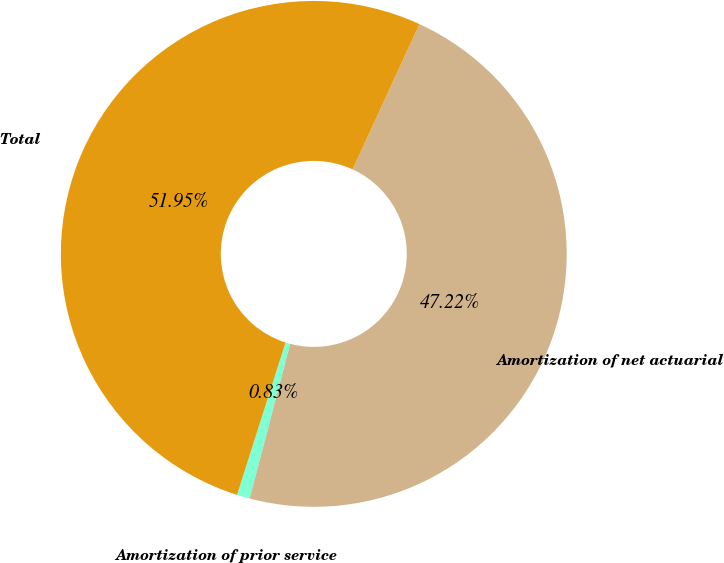<chart> <loc_0><loc_0><loc_500><loc_500><pie_chart><fcel>Amortization of prior service<fcel>Amortization of net actuarial<fcel>Total<nl><fcel>0.83%<fcel>47.22%<fcel>51.95%<nl></chart> 